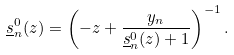<formula> <loc_0><loc_0><loc_500><loc_500>\underline { s } _ { n } ^ { 0 } ( z ) = \left ( - z + \frac { y _ { n } } { \underline { s } _ { n } ^ { 0 } ( z ) + 1 } \right ) ^ { - 1 } .</formula> 